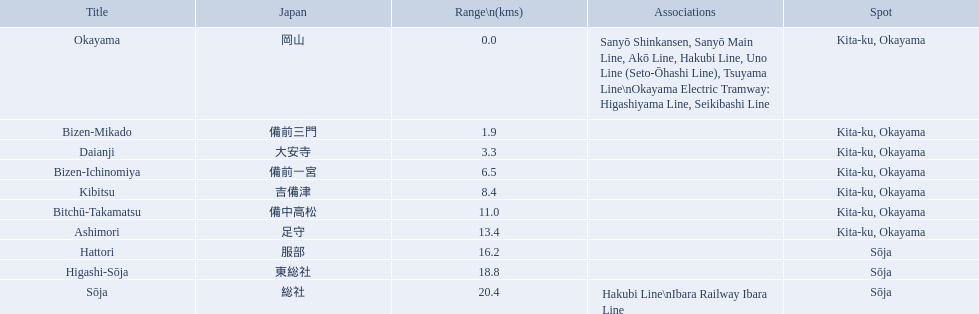What are the members of the kibi line? Okayama, Bizen-Mikado, Daianji, Bizen-Ichinomiya, Kibitsu, Bitchū-Takamatsu, Ashimori, Hattori, Higashi-Sōja, Sōja. Which of them have a distance of more than 1 km? Bizen-Mikado, Daianji, Bizen-Ichinomiya, Kibitsu, Bitchū-Takamatsu, Ashimori, Hattori, Higashi-Sōja, Sōja. Which of them have a distance of less than 2 km? Okayama, Bizen-Mikado. Which has a distance between 1 km and 2 km? Bizen-Mikado. 